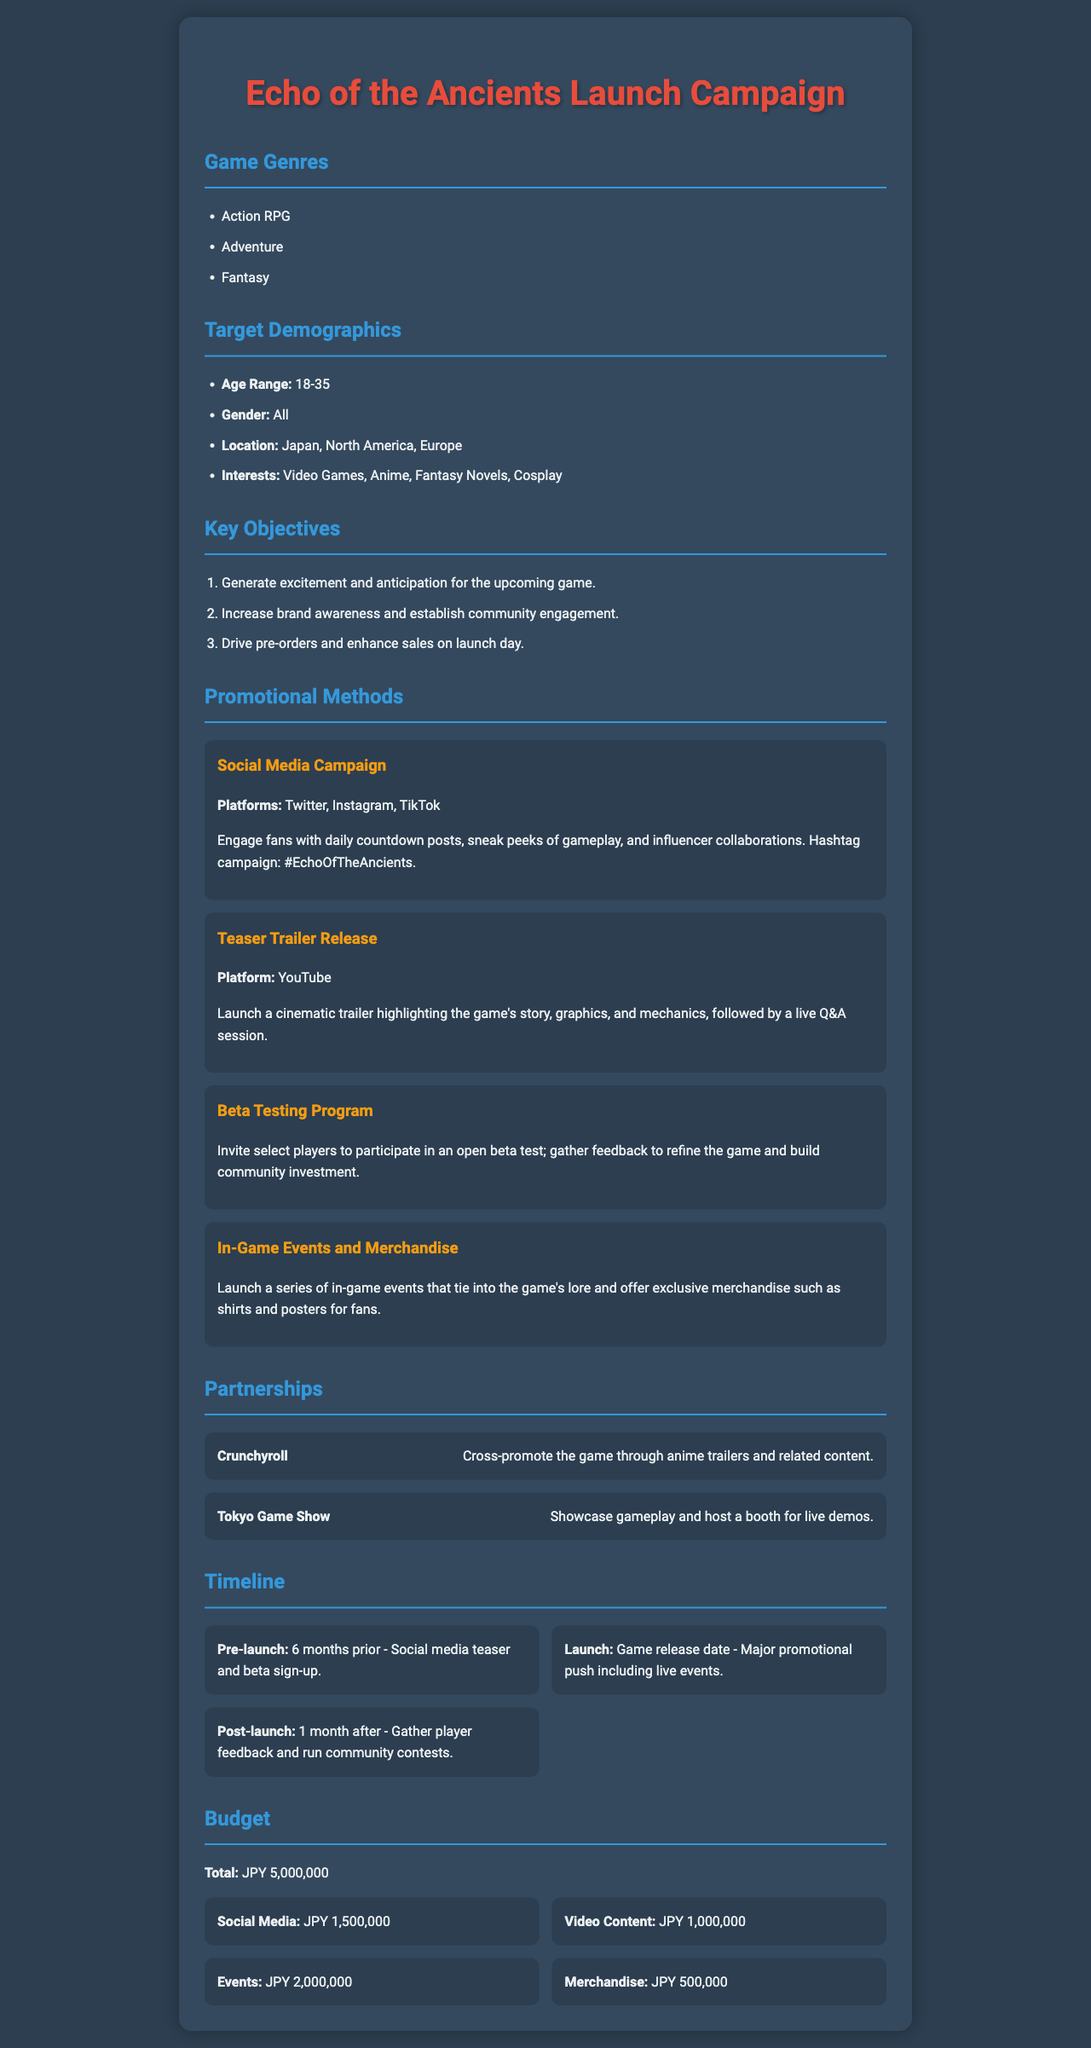What is the age range of the target demographics? The age range of the target demographics is specified in the document under Target Demographics.
Answer: 18-35 Which promotional method involves inviting select players to test the game? This method is detailed under Promotional Methods in the document.
Answer: Beta Testing Program What is the total budget for the marketing campaign? The total budget is listed in the Budget section of the document.
Answer: JPY 5,000,000 What are the interests of the target demographics? The interests are mentioned in the Target Demographics section and list specific areas relevant to the audience.
Answer: Video Games, Anime, Fantasy Novels, Cosplay Which platforms are used for the social media campaign? The platforms for the social media campaign are outlined in the Promotional Methods section.
Answer: Twitter, Instagram, TikTok What type of game is "Echo of the Ancients"? The genre of the game is specified at the beginning of the document.
Answer: Action RPG, Adventure, Fantasy How much is allocated for video content in the budget? This specific allocation is provided within the Budget section of the document.
Answer: JPY 1,000,000 What is one of the key objectives of the campaign? The objectives are listed under Key Objectives in the document, detailing the campaign's goals.
Answer: Generate excitement and anticipation for the upcoming game 